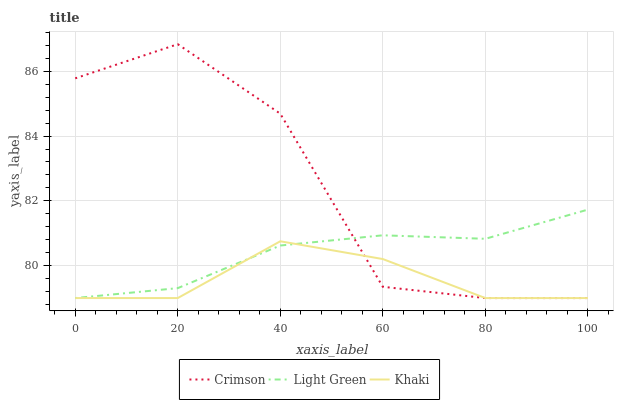Does Light Green have the minimum area under the curve?
Answer yes or no. No. Does Light Green have the maximum area under the curve?
Answer yes or no. No. Is Khaki the smoothest?
Answer yes or no. No. Is Khaki the roughest?
Answer yes or no. No. Does Light Green have the highest value?
Answer yes or no. No. 